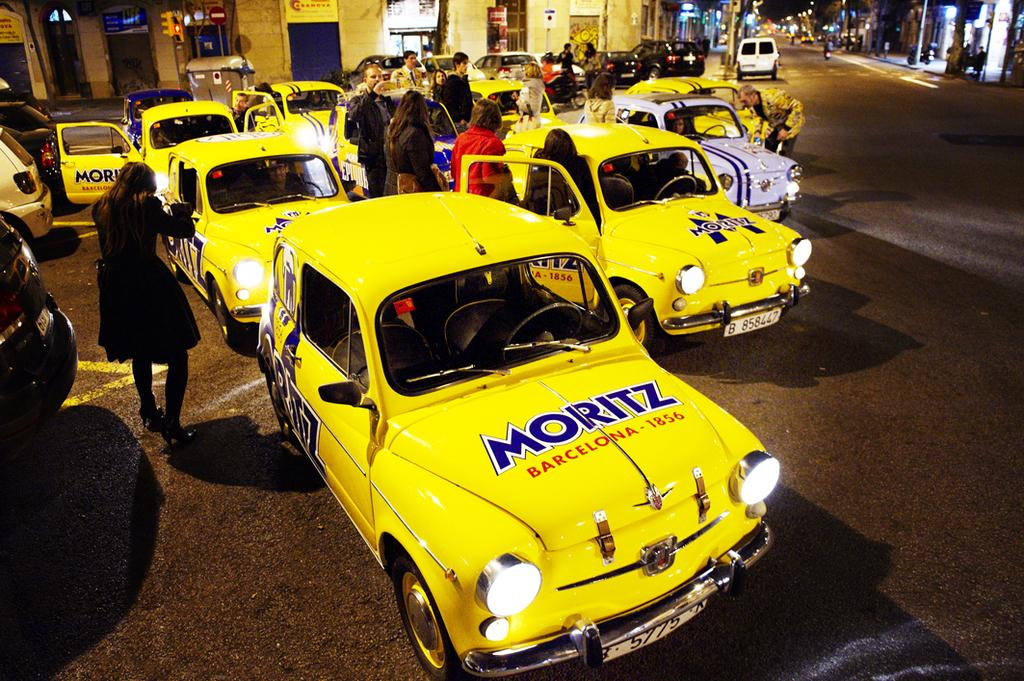<image>
Render a clear and concise summary of the photo. some cars with the name Moritz on it 